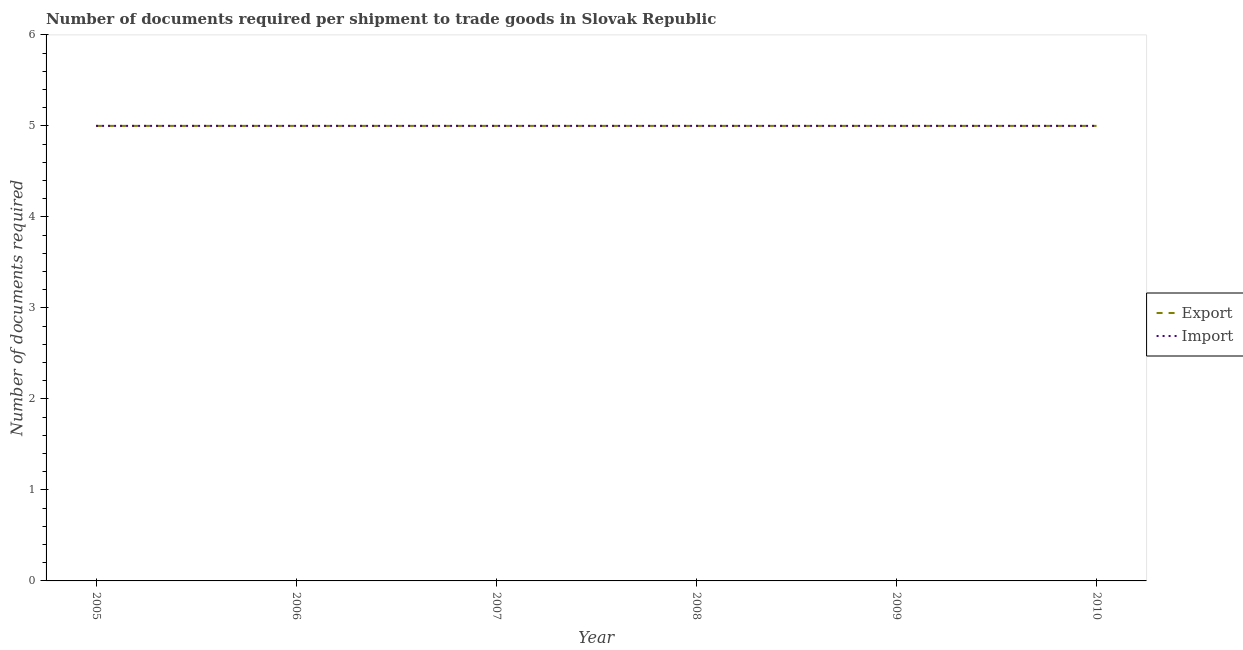Is the number of lines equal to the number of legend labels?
Make the answer very short. Yes. What is the number of documents required to export goods in 2010?
Provide a short and direct response. 5. Across all years, what is the maximum number of documents required to import goods?
Your response must be concise. 5. Across all years, what is the minimum number of documents required to export goods?
Offer a very short reply. 5. In which year was the number of documents required to export goods minimum?
Provide a short and direct response. 2005. What is the total number of documents required to export goods in the graph?
Your response must be concise. 30. What is the difference between the number of documents required to export goods in 2005 and that in 2006?
Give a very brief answer. 0. What is the average number of documents required to export goods per year?
Your response must be concise. 5. In the year 2009, what is the difference between the number of documents required to import goods and number of documents required to export goods?
Your answer should be compact. 0. In how many years, is the number of documents required to export goods greater than 0.4?
Give a very brief answer. 6. Is the number of documents required to export goods in 2006 less than that in 2007?
Ensure brevity in your answer.  No. Is the difference between the number of documents required to import goods in 2008 and 2009 greater than the difference between the number of documents required to export goods in 2008 and 2009?
Offer a terse response. No. What is the difference between the highest and the second highest number of documents required to export goods?
Make the answer very short. 0. In how many years, is the number of documents required to import goods greater than the average number of documents required to import goods taken over all years?
Give a very brief answer. 0. Is the sum of the number of documents required to import goods in 2007 and 2009 greater than the maximum number of documents required to export goods across all years?
Your answer should be very brief. Yes. How many years are there in the graph?
Give a very brief answer. 6. What is the difference between two consecutive major ticks on the Y-axis?
Your response must be concise. 1. Does the graph contain any zero values?
Your response must be concise. No. How many legend labels are there?
Provide a succinct answer. 2. How are the legend labels stacked?
Keep it short and to the point. Vertical. What is the title of the graph?
Provide a succinct answer. Number of documents required per shipment to trade goods in Slovak Republic. What is the label or title of the X-axis?
Your response must be concise. Year. What is the label or title of the Y-axis?
Provide a short and direct response. Number of documents required. What is the Number of documents required of Import in 2005?
Your response must be concise. 5. What is the Number of documents required of Export in 2006?
Offer a very short reply. 5. What is the Number of documents required of Export in 2008?
Give a very brief answer. 5. What is the Number of documents required in Export in 2009?
Make the answer very short. 5. What is the Number of documents required of Import in 2010?
Offer a terse response. 5. Across all years, what is the minimum Number of documents required in Import?
Offer a terse response. 5. What is the total Number of documents required of Export in the graph?
Provide a succinct answer. 30. What is the difference between the Number of documents required in Export in 2005 and that in 2006?
Provide a short and direct response. 0. What is the difference between the Number of documents required of Import in 2005 and that in 2007?
Provide a short and direct response. 0. What is the difference between the Number of documents required of Import in 2005 and that in 2009?
Your answer should be compact. 0. What is the difference between the Number of documents required in Import in 2006 and that in 2007?
Offer a terse response. 0. What is the difference between the Number of documents required of Import in 2006 and that in 2008?
Provide a succinct answer. 0. What is the difference between the Number of documents required in Import in 2006 and that in 2009?
Make the answer very short. 0. What is the difference between the Number of documents required in Import in 2006 and that in 2010?
Give a very brief answer. 0. What is the difference between the Number of documents required in Export in 2007 and that in 2008?
Your response must be concise. 0. What is the difference between the Number of documents required of Import in 2007 and that in 2008?
Provide a short and direct response. 0. What is the difference between the Number of documents required in Export in 2007 and that in 2009?
Provide a succinct answer. 0. What is the difference between the Number of documents required of Import in 2008 and that in 2009?
Provide a short and direct response. 0. What is the difference between the Number of documents required in Export in 2008 and that in 2010?
Your response must be concise. 0. What is the difference between the Number of documents required of Export in 2009 and that in 2010?
Offer a very short reply. 0. What is the difference between the Number of documents required of Import in 2009 and that in 2010?
Offer a terse response. 0. What is the difference between the Number of documents required in Export in 2005 and the Number of documents required in Import in 2006?
Your response must be concise. 0. What is the difference between the Number of documents required in Export in 2005 and the Number of documents required in Import in 2007?
Ensure brevity in your answer.  0. What is the difference between the Number of documents required in Export in 2005 and the Number of documents required in Import in 2010?
Ensure brevity in your answer.  0. What is the difference between the Number of documents required of Export in 2006 and the Number of documents required of Import in 2010?
Keep it short and to the point. 0. What is the difference between the Number of documents required in Export in 2007 and the Number of documents required in Import in 2010?
Your answer should be compact. 0. What is the difference between the Number of documents required in Export in 2008 and the Number of documents required in Import in 2009?
Make the answer very short. 0. What is the difference between the Number of documents required of Export in 2009 and the Number of documents required of Import in 2010?
Offer a terse response. 0. What is the average Number of documents required of Export per year?
Give a very brief answer. 5. What is the average Number of documents required in Import per year?
Your answer should be compact. 5. In the year 2006, what is the difference between the Number of documents required of Export and Number of documents required of Import?
Keep it short and to the point. 0. In the year 2010, what is the difference between the Number of documents required of Export and Number of documents required of Import?
Ensure brevity in your answer.  0. What is the ratio of the Number of documents required in Import in 2005 to that in 2006?
Give a very brief answer. 1. What is the ratio of the Number of documents required in Import in 2005 to that in 2007?
Keep it short and to the point. 1. What is the ratio of the Number of documents required of Export in 2005 to that in 2008?
Your response must be concise. 1. What is the ratio of the Number of documents required in Export in 2005 to that in 2009?
Offer a very short reply. 1. What is the ratio of the Number of documents required of Import in 2005 to that in 2009?
Provide a succinct answer. 1. What is the ratio of the Number of documents required of Export in 2005 to that in 2010?
Make the answer very short. 1. What is the ratio of the Number of documents required of Import in 2005 to that in 2010?
Your response must be concise. 1. What is the ratio of the Number of documents required of Export in 2006 to that in 2007?
Make the answer very short. 1. What is the ratio of the Number of documents required in Import in 2006 to that in 2007?
Offer a very short reply. 1. What is the ratio of the Number of documents required of Export in 2006 to that in 2008?
Offer a terse response. 1. What is the ratio of the Number of documents required in Import in 2006 to that in 2008?
Your answer should be compact. 1. What is the ratio of the Number of documents required in Export in 2006 to that in 2009?
Offer a very short reply. 1. What is the ratio of the Number of documents required in Import in 2006 to that in 2009?
Provide a succinct answer. 1. What is the ratio of the Number of documents required of Export in 2006 to that in 2010?
Keep it short and to the point. 1. What is the ratio of the Number of documents required in Import in 2006 to that in 2010?
Provide a succinct answer. 1. What is the ratio of the Number of documents required of Export in 2007 to that in 2008?
Your response must be concise. 1. What is the ratio of the Number of documents required of Export in 2007 to that in 2009?
Provide a succinct answer. 1. What is the ratio of the Number of documents required in Export in 2007 to that in 2010?
Offer a terse response. 1. What is the ratio of the Number of documents required in Import in 2007 to that in 2010?
Ensure brevity in your answer.  1. What is the ratio of the Number of documents required in Export in 2009 to that in 2010?
Make the answer very short. 1. 